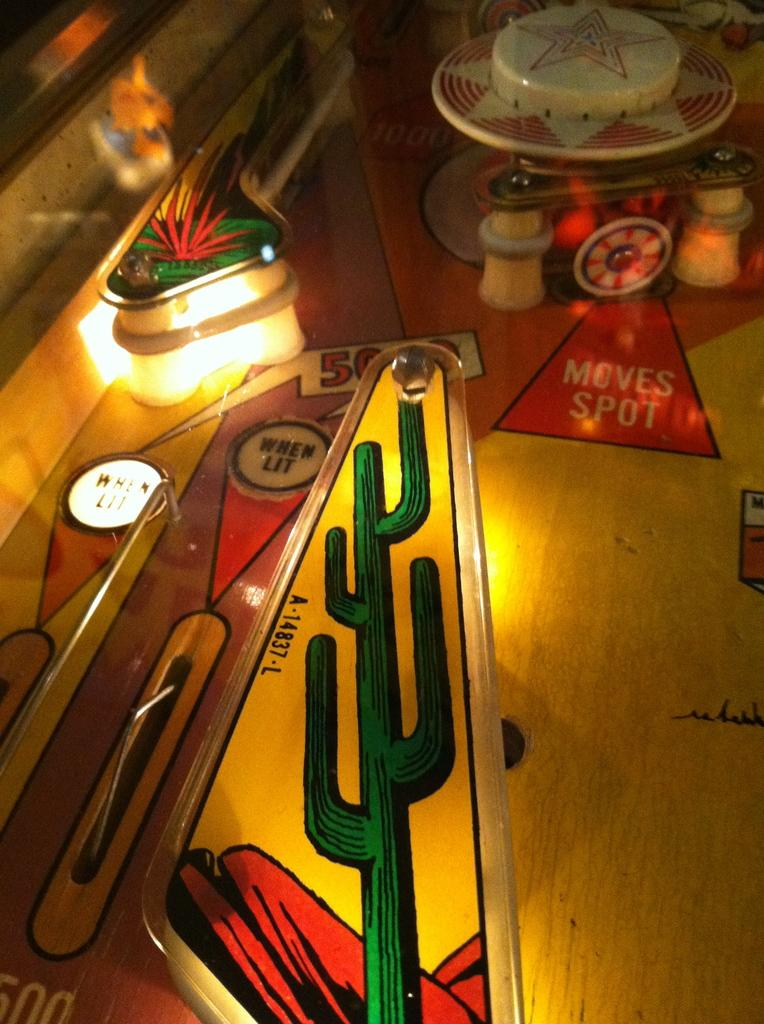What is the main object in the image? There is a gaming instrument in the image. What material is the gaming instrument made of? The gaming instrument is made of wood. What type of vacation is being planned with the gaming instrument in the image? There is no indication of a vacation or any planning in the image; it only features a wooden gaming instrument. 